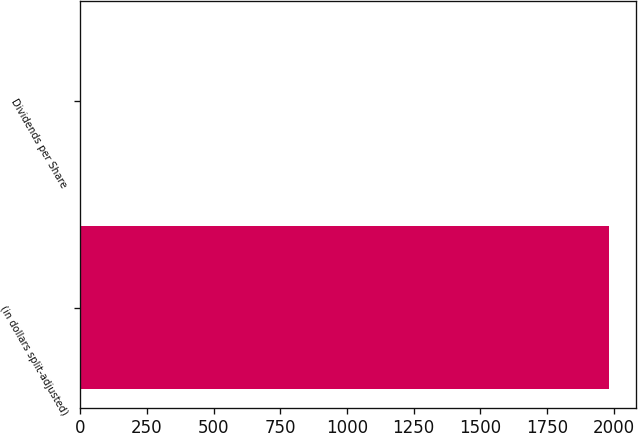Convert chart to OTSL. <chart><loc_0><loc_0><loc_500><loc_500><bar_chart><fcel>(in dollars split-adjusted)<fcel>Dividends per Share<nl><fcel>1984<fcel>0.15<nl></chart> 